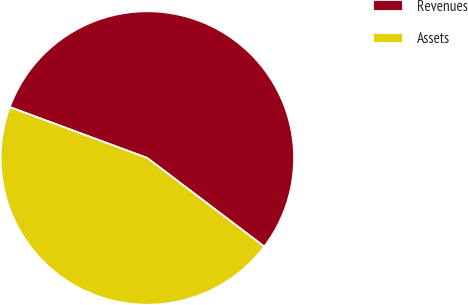Convert chart to OTSL. <chart><loc_0><loc_0><loc_500><loc_500><pie_chart><fcel>Revenues<fcel>Assets<nl><fcel>54.67%<fcel>45.33%<nl></chart> 